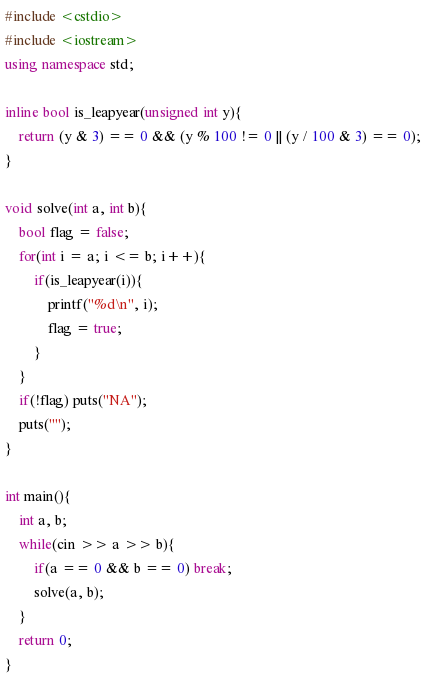<code> <loc_0><loc_0><loc_500><loc_500><_C++_>#include <cstdio>
#include <iostream>
using namespace std;

inline bool is_leapyear(unsigned int y){
    return (y & 3) == 0 && (y % 100 != 0 || (y / 100 & 3) == 0);
}

void solve(int a, int b){
    bool flag = false;
    for(int i = a; i <= b; i++){
        if(is_leapyear(i)){
            printf("%d\n", i);
            flag = true;
        }
    }
    if(!flag) puts("NA");
    puts("");
}

int main(){
    int a, b;
    while(cin >> a >> b){
        if(a == 0 && b == 0) break;
        solve(a, b);
    }
    return 0;
}</code> 